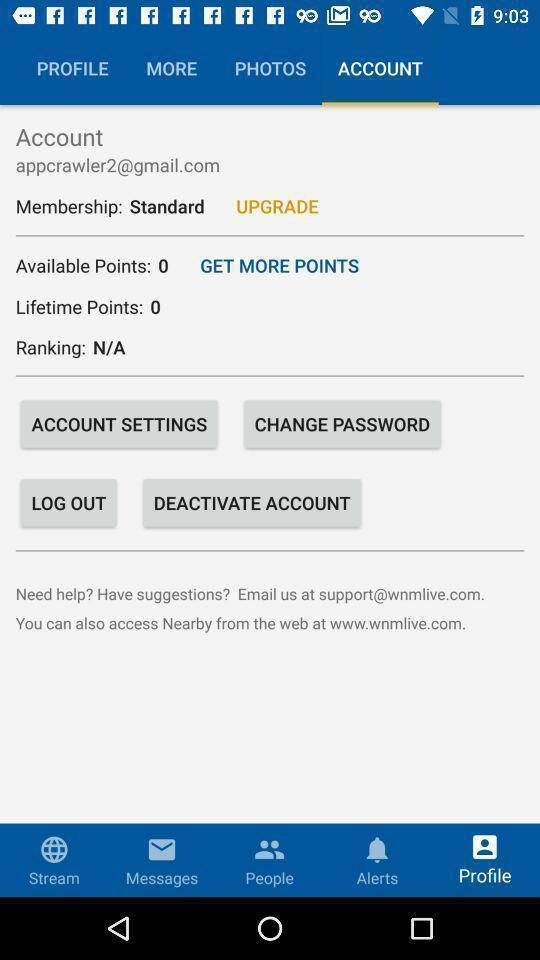Explain what's happening in this screen capture. Screen showing account page. 